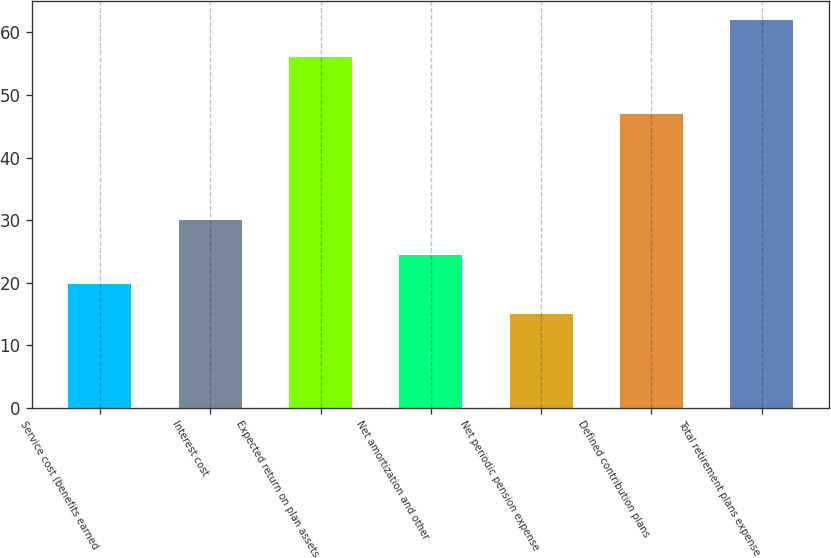Convert chart. <chart><loc_0><loc_0><loc_500><loc_500><bar_chart><fcel>Service cost (benefits earned<fcel>Interest cost<fcel>Expected return on plan assets<fcel>Net amortization and other<fcel>Net periodic pension expense<fcel>Defined contribution plans<fcel>Total retirement plans expense<nl><fcel>19.7<fcel>30<fcel>56<fcel>24.4<fcel>15<fcel>47<fcel>62<nl></chart> 